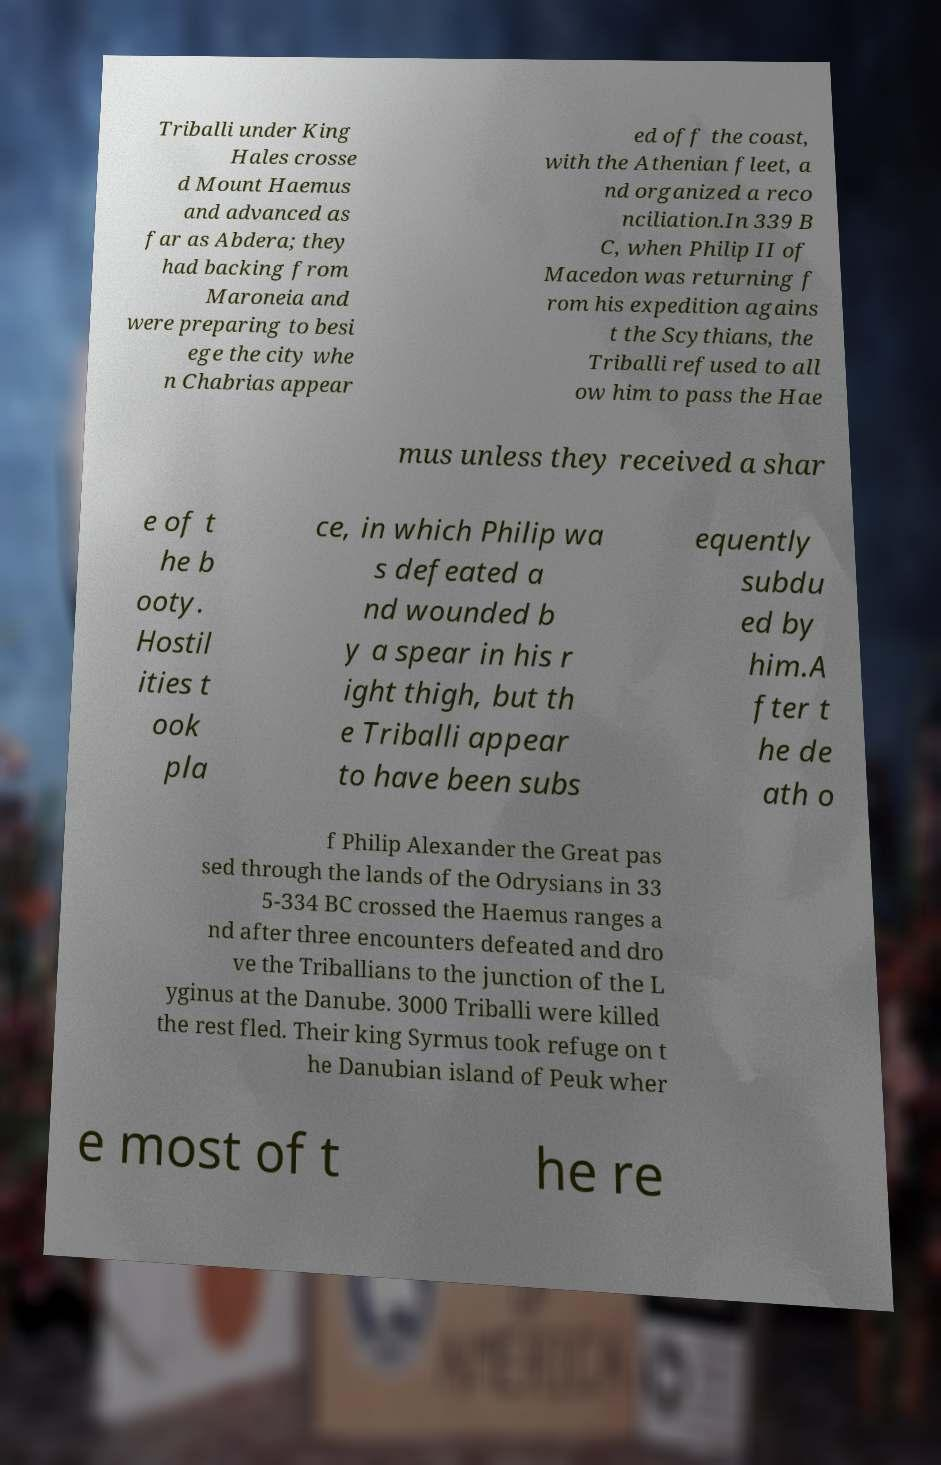There's text embedded in this image that I need extracted. Can you transcribe it verbatim? Triballi under King Hales crosse d Mount Haemus and advanced as far as Abdera; they had backing from Maroneia and were preparing to besi ege the city whe n Chabrias appear ed off the coast, with the Athenian fleet, a nd organized a reco nciliation.In 339 B C, when Philip II of Macedon was returning f rom his expedition agains t the Scythians, the Triballi refused to all ow him to pass the Hae mus unless they received a shar e of t he b ooty. Hostil ities t ook pla ce, in which Philip wa s defeated a nd wounded b y a spear in his r ight thigh, but th e Triballi appear to have been subs equently subdu ed by him.A fter t he de ath o f Philip Alexander the Great pas sed through the lands of the Odrysians in 33 5-334 BC crossed the Haemus ranges a nd after three encounters defeated and dro ve the Triballians to the junction of the L yginus at the Danube. 3000 Triballi were killed the rest fled. Their king Syrmus took refuge on t he Danubian island of Peuk wher e most of t he re 